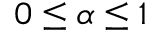<formula> <loc_0><loc_0><loc_500><loc_500>0 \leq \alpha \leq 1</formula> 